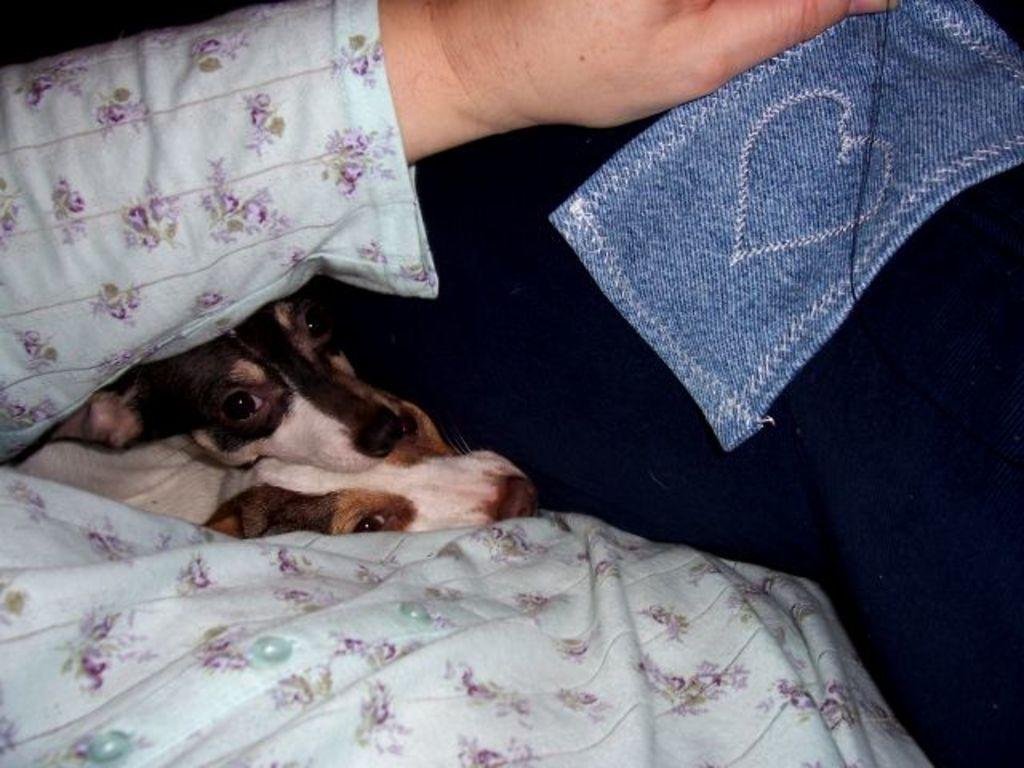Describe this image in one or two sentences. In this image, we can see a person sitting and holding a cloth, we can see some puppies. 